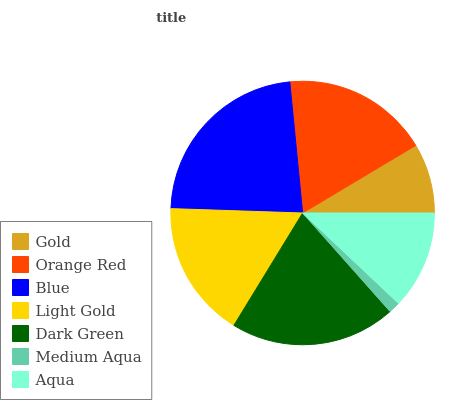Is Medium Aqua the minimum?
Answer yes or no. Yes. Is Blue the maximum?
Answer yes or no. Yes. Is Orange Red the minimum?
Answer yes or no. No. Is Orange Red the maximum?
Answer yes or no. No. Is Orange Red greater than Gold?
Answer yes or no. Yes. Is Gold less than Orange Red?
Answer yes or no. Yes. Is Gold greater than Orange Red?
Answer yes or no. No. Is Orange Red less than Gold?
Answer yes or no. No. Is Light Gold the high median?
Answer yes or no. Yes. Is Light Gold the low median?
Answer yes or no. Yes. Is Dark Green the high median?
Answer yes or no. No. Is Medium Aqua the low median?
Answer yes or no. No. 